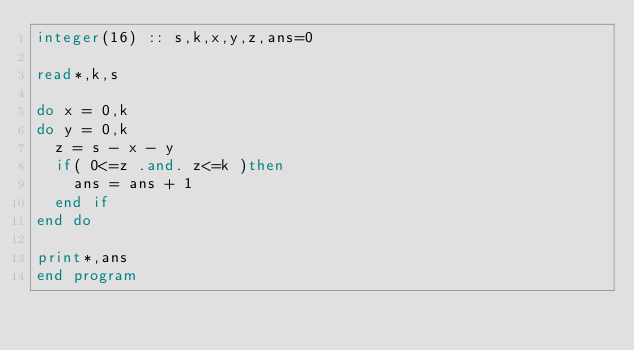<code> <loc_0><loc_0><loc_500><loc_500><_FORTRAN_>integer(16) :: s,k,x,y,z,ans=0

read*,k,s

do x = 0,k
do y = 0,k
  z = s - x - y
  if( 0<=z .and. z<=k )then
    ans = ans + 1
  end if
end do

print*,ans
end program</code> 